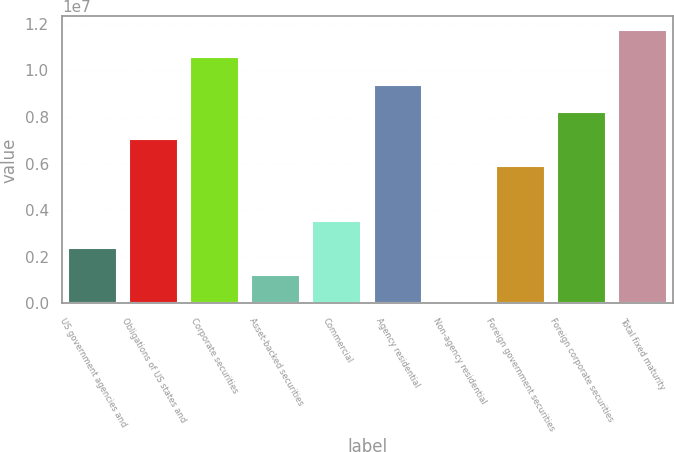<chart> <loc_0><loc_0><loc_500><loc_500><bar_chart><fcel>US government agencies and<fcel>Obligations of US states and<fcel>Corporate securities<fcel>Asset-backed securities<fcel>Commercial<fcel>Agency residential<fcel>Non-agency residential<fcel>Foreign government securities<fcel>Foreign corporate securities<fcel>Total fixed maturity<nl><fcel>2.38893e+06<fcel>7.06005e+06<fcel>1.05634e+07<fcel>1.22115e+06<fcel>3.55671e+06<fcel>9.39561e+06<fcel>53365<fcel>5.89227e+06<fcel>8.22783e+06<fcel>1.17312e+07<nl></chart> 